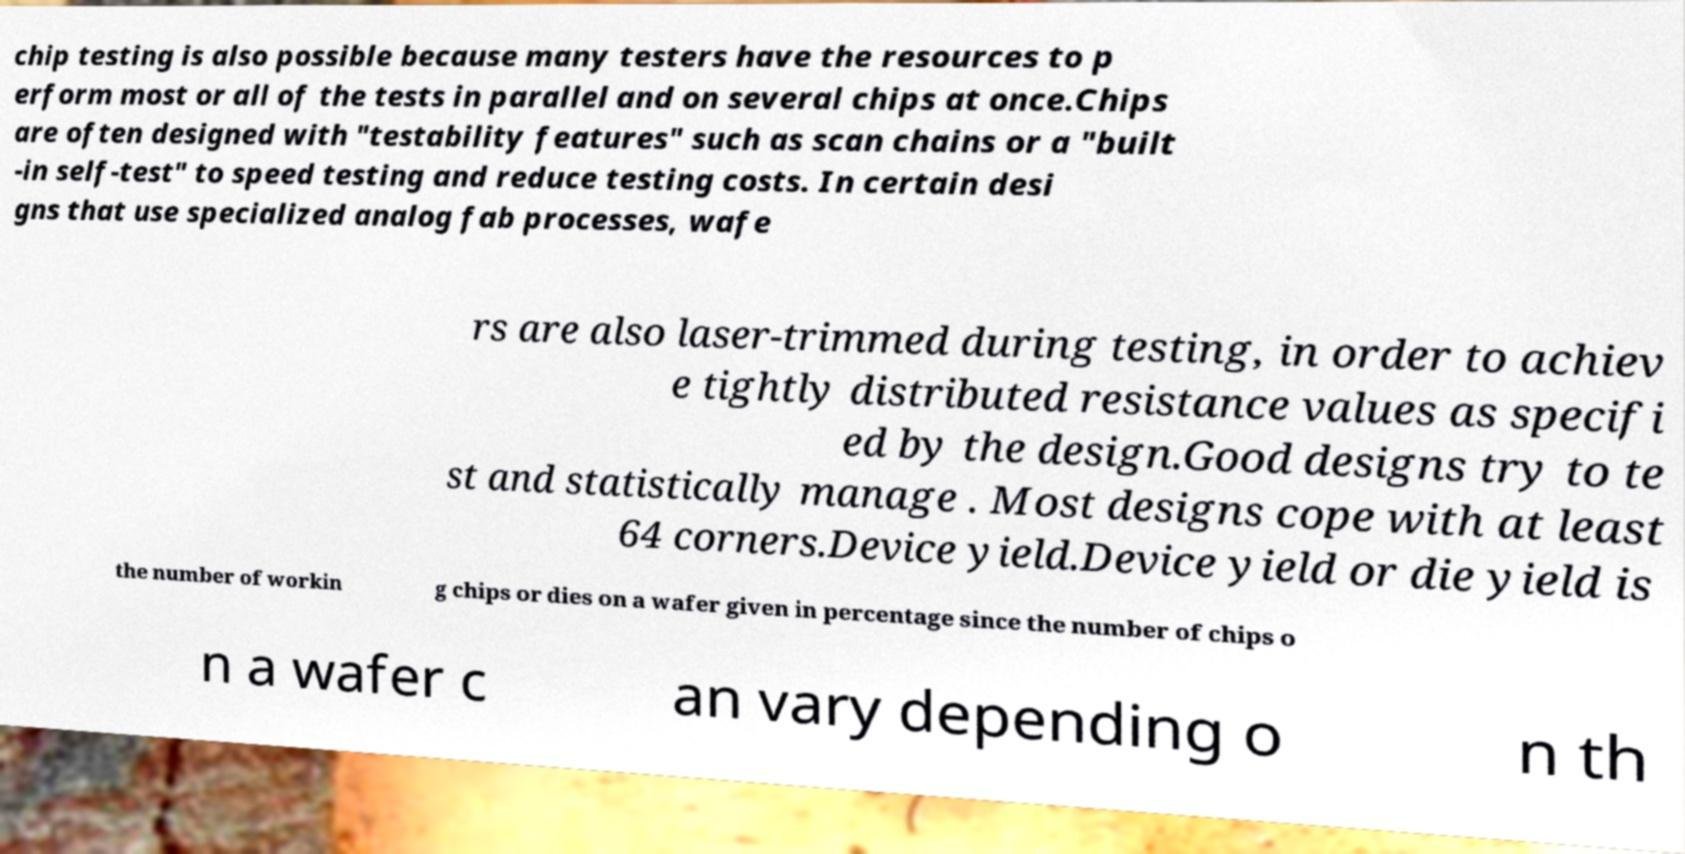Can you read and provide the text displayed in the image?This photo seems to have some interesting text. Can you extract and type it out for me? chip testing is also possible because many testers have the resources to p erform most or all of the tests in parallel and on several chips at once.Chips are often designed with "testability features" such as scan chains or a "built -in self-test" to speed testing and reduce testing costs. In certain desi gns that use specialized analog fab processes, wafe rs are also laser-trimmed during testing, in order to achiev e tightly distributed resistance values as specifi ed by the design.Good designs try to te st and statistically manage . Most designs cope with at least 64 corners.Device yield.Device yield or die yield is the number of workin g chips or dies on a wafer given in percentage since the number of chips o n a wafer c an vary depending o n th 